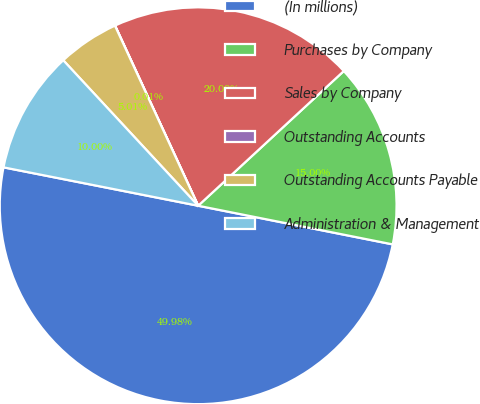Convert chart to OTSL. <chart><loc_0><loc_0><loc_500><loc_500><pie_chart><fcel>(In millions)<fcel>Purchases by Company<fcel>Sales by Company<fcel>Outstanding Accounts<fcel>Outstanding Accounts Payable<fcel>Administration & Management<nl><fcel>49.98%<fcel>15.0%<fcel>20.0%<fcel>0.01%<fcel>5.01%<fcel>10.0%<nl></chart> 